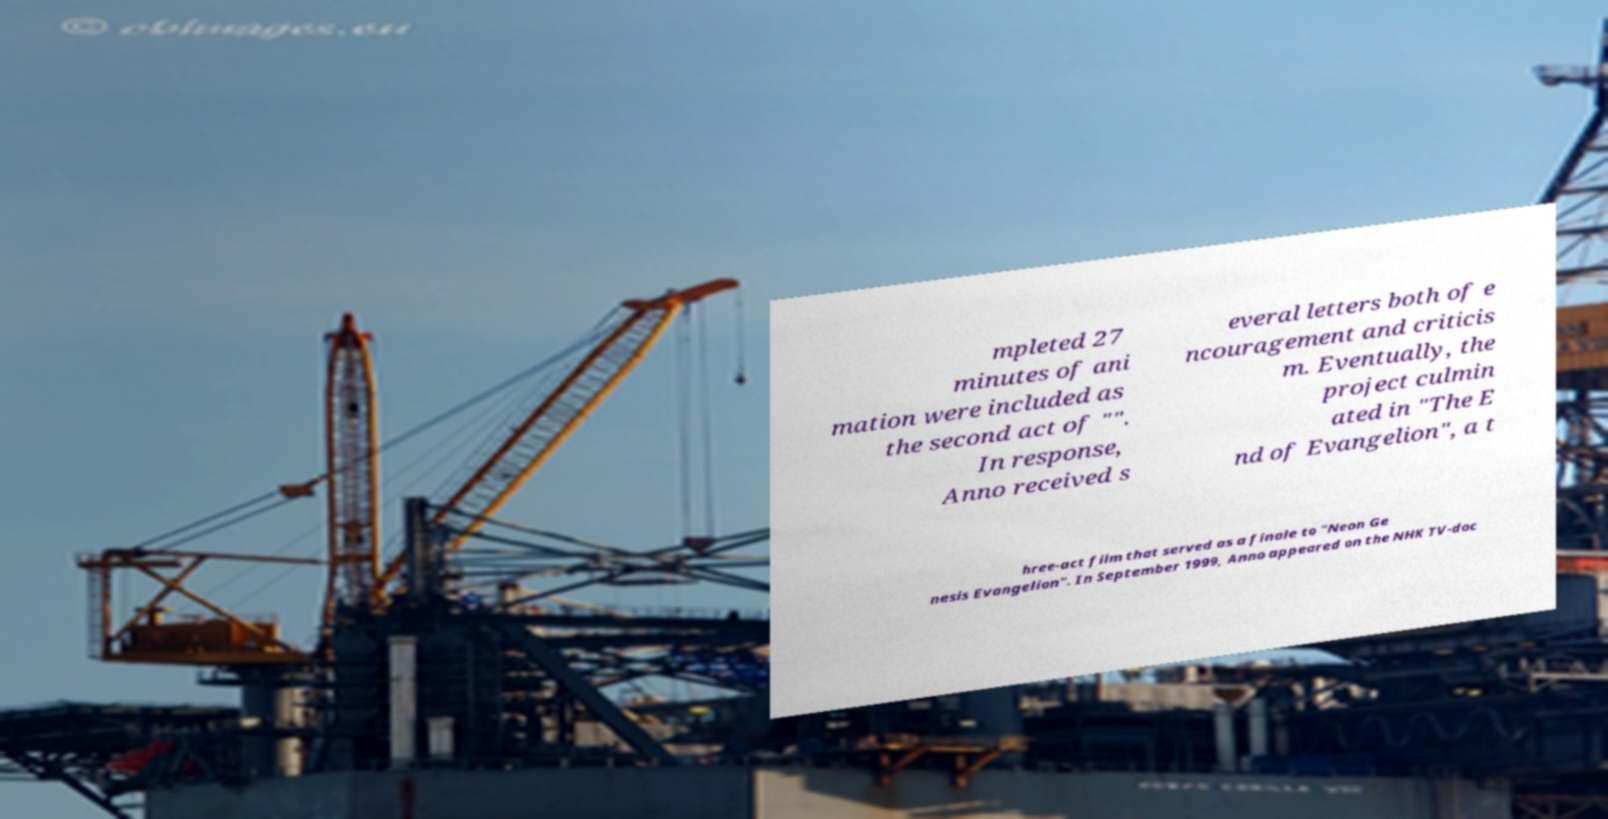Could you extract and type out the text from this image? mpleted 27 minutes of ani mation were included as the second act of "". In response, Anno received s everal letters both of e ncouragement and criticis m. Eventually, the project culmin ated in "The E nd of Evangelion", a t hree-act film that served as a finale to "Neon Ge nesis Evangelion". In September 1999, Anno appeared on the NHK TV-doc 